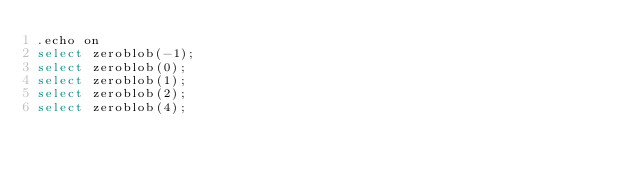<code> <loc_0><loc_0><loc_500><loc_500><_SQL_>.echo on
select zeroblob(-1);
select zeroblob(0);
select zeroblob(1);
select zeroblob(2);
select zeroblob(4);

</code> 